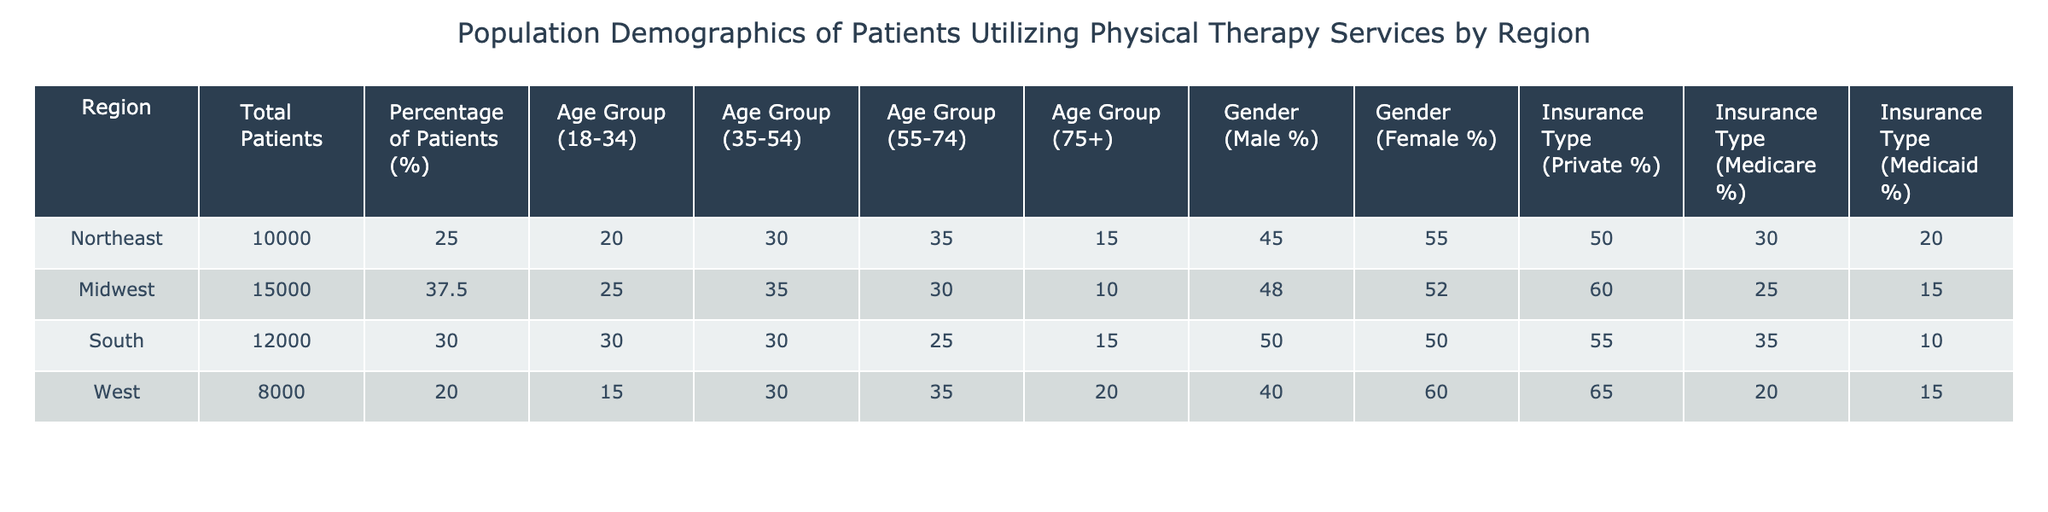What region has the highest percentage of patients utilizing physical therapy services? The Northeast region has the highest percentage of patients at 25%. This is directly obtained by looking at the "Percentage of Patients (%)" column and identifying the highest value.
Answer: Northeast How many total patients are utilizing physical therapy services in the Midwest? The total number of patients in the Midwest is stated in the "Total Patients" column, which shows 15000.
Answer: 15000 What age group has the lowest percentage of patients in the South? The age group 75+ has the lowest percentage of patients using physical therapy services in the South, at 15%. This can be found by comparing the percentages in the "Age Group (75+)" column for the South row.
Answer: 15% Is there a greater percentage of female patients than male patients in the West? Yes, in the West region, the percentage of female patients is 60%, while the percentage of male patients is 40%. Since 60% is greater than 40%, the answer is yes.
Answer: Yes What is the total percentage of patients utilizing Medicare in the Northeast and Midwest combined? The percentage of patients utilizing Medicare in the Northeast is 30% and in the Midwest is 25%. Adding these together gives 30% + 25% = 55%.
Answer: 55% Which region has the lowest total patients utilizing physical therapy services? The West region has the lowest total number of patients at 8000, as noted in the "Total Patients" column. This is the smallest value among all regions.
Answer: West What percentage of patients in the Midwest are covered by Medicaid? In the Midwest, the percentage of patients covered by Medicaid is 15%. This can be found in the "Insurance Type (Medicaid %)" column for the Midwest row.
Answer: 15% Which age group represents the highest percentage of patients in the Northeast? The age group 55-74 represents the highest percentage of patients in the Northeast at 35%. This value is obtained from the "Age Group (55-74)" column for the Northeast row, which is the highest among the age groups listed.
Answer: 35% How does the percentage of private insurance in the South compare to the percentage in the Midwest? The South has 55% of patients covered by private insurance, while the Midwest has 60%. Therefore, the percentage in the Southeast (55%) is lower than in the Midwest (60%).
Answer: Lower 